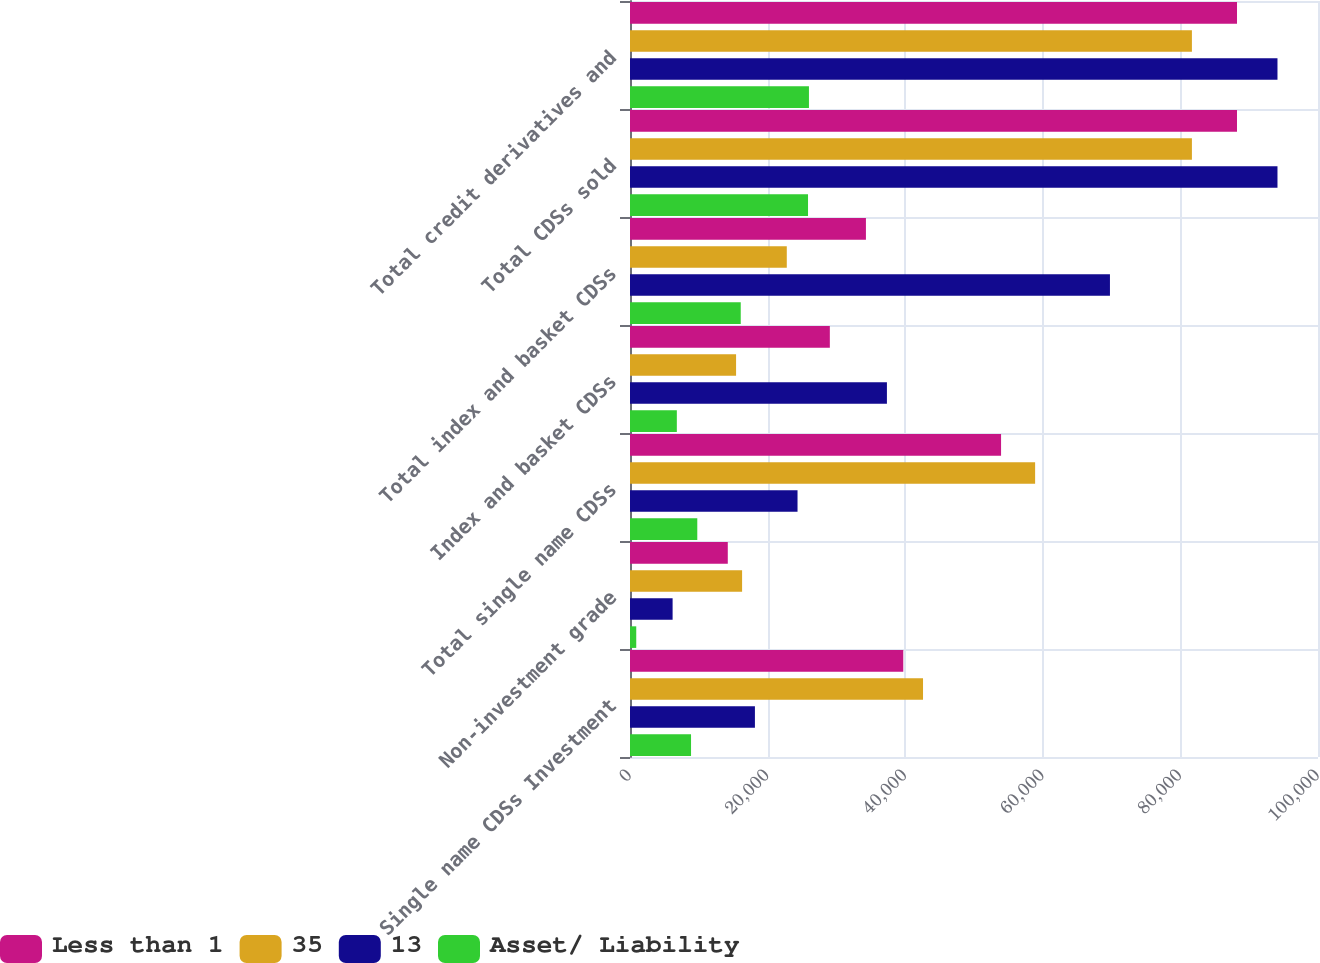Convert chart. <chart><loc_0><loc_0><loc_500><loc_500><stacked_bar_chart><ecel><fcel>Single name CDSs Investment<fcel>Non-investment grade<fcel>Total single name CDSs<fcel>Index and basket CDSs<fcel>Total index and basket CDSs<fcel>Total CDSs sold<fcel>Total credit derivatives and<nl><fcel>Less than 1<fcel>39721<fcel>14213<fcel>53934<fcel>29046<fcel>34292<fcel>88226<fcel>88228<nl><fcel>35<fcel>42591<fcel>16293<fcel>58884<fcel>15418<fcel>22789<fcel>81673<fcel>81673<nl><fcel>13<fcel>18157<fcel>6193<fcel>24350<fcel>37343<fcel>69760<fcel>94110<fcel>94110<nl><fcel>Asset/ Liability<fcel>8872<fcel>908<fcel>9780<fcel>6807<fcel>16096<fcel>25876<fcel>26010<nl></chart> 